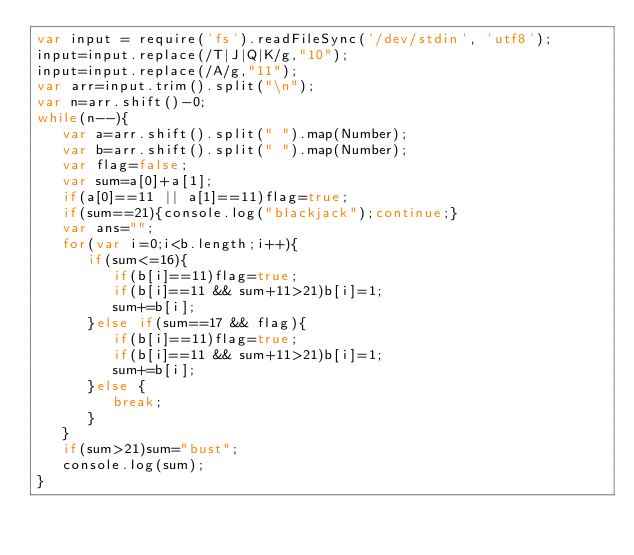<code> <loc_0><loc_0><loc_500><loc_500><_JavaScript_>var input = require('fs').readFileSync('/dev/stdin', 'utf8');
input=input.replace(/T|J|Q|K/g,"10");
input=input.replace(/A/g,"11");
var arr=input.trim().split("\n");
var n=arr.shift()-0;
while(n--){
   var a=arr.shift().split(" ").map(Number);
   var b=arr.shift().split(" ").map(Number);
   var flag=false;
   var sum=a[0]+a[1];
   if(a[0]==11 || a[1]==11)flag=true;
   if(sum==21){console.log("blackjack");continue;}
   var ans="";
   for(var i=0;i<b.length;i++){
      if(sum<=16){
         if(b[i]==11)flag=true;
         if(b[i]==11 && sum+11>21)b[i]=1;
         sum+=b[i];
      }else if(sum==17 && flag){
         if(b[i]==11)flag=true;
         if(b[i]==11 && sum+11>21)b[i]=1;
         sum+=b[i];
      }else {
         break;
      }
   }
   if(sum>21)sum="bust";
   console.log(sum);
}</code> 